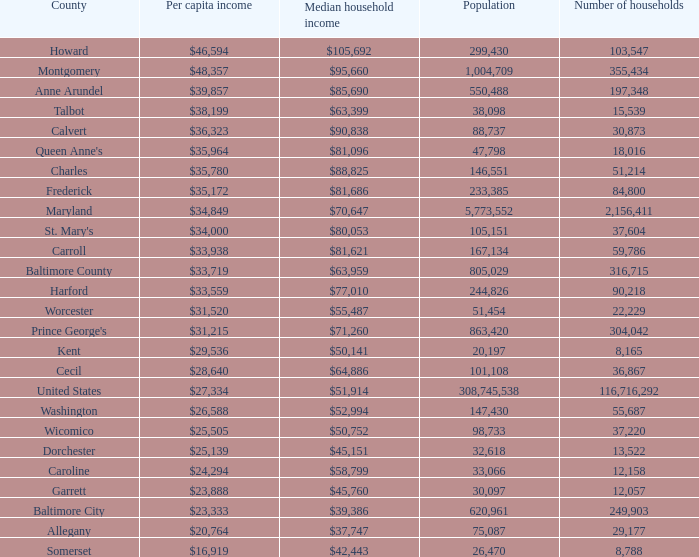Would you be able to parse every entry in this table? {'header': ['County', 'Per capita income', 'Median household income', 'Population', 'Number of households'], 'rows': [['Howard', '$46,594', '$105,692', '299,430', '103,547'], ['Montgomery', '$48,357', '$95,660', '1,004,709', '355,434'], ['Anne Arundel', '$39,857', '$85,690', '550,488', '197,348'], ['Talbot', '$38,199', '$63,399', '38,098', '15,539'], ['Calvert', '$36,323', '$90,838', '88,737', '30,873'], ["Queen Anne's", '$35,964', '$81,096', '47,798', '18,016'], ['Charles', '$35,780', '$88,825', '146,551', '51,214'], ['Frederick', '$35,172', '$81,686', '233,385', '84,800'], ['Maryland', '$34,849', '$70,647', '5,773,552', '2,156,411'], ["St. Mary's", '$34,000', '$80,053', '105,151', '37,604'], ['Carroll', '$33,938', '$81,621', '167,134', '59,786'], ['Baltimore County', '$33,719', '$63,959', '805,029', '316,715'], ['Harford', '$33,559', '$77,010', '244,826', '90,218'], ['Worcester', '$31,520', '$55,487', '51,454', '22,229'], ["Prince George's", '$31,215', '$71,260', '863,420', '304,042'], ['Kent', '$29,536', '$50,141', '20,197', '8,165'], ['Cecil', '$28,640', '$64,886', '101,108', '36,867'], ['United States', '$27,334', '$51,914', '308,745,538', '116,716,292'], ['Washington', '$26,588', '$52,994', '147,430', '55,687'], ['Wicomico', '$25,505', '$50,752', '98,733', '37,220'], ['Dorchester', '$25,139', '$45,151', '32,618', '13,522'], ['Caroline', '$24,294', '$58,799', '33,066', '12,158'], ['Garrett', '$23,888', '$45,760', '30,097', '12,057'], ['Baltimore City', '$23,333', '$39,386', '620,961', '249,903'], ['Allegany', '$20,764', '$37,747', '75,087', '29,177'], ['Somerset', '$16,919', '$42,443', '26,470', '8,788']]} What is the per capital income for Washington county? $26,588. 